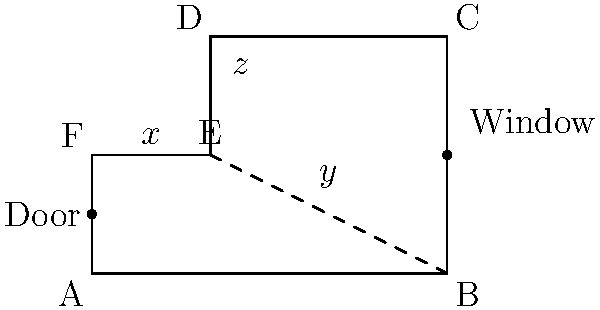In this floor plan of a locked-room mystery scenario, angles $x$, $y$, and $z$ form a crucial part of the crime scene. If $x = 90°$ and $y = 60°$, what is the value of $z$? To solve this problem, we need to follow these steps:

1) First, observe that triangle BDE is formed by the dashed line connecting points B and E.

2) In any triangle, the sum of all interior angles is always 180°. Therefore:
   
   $x + y + z = 180°$

3) We are given that $x = 90°$ and $y = 60°$. Let's substitute these values:
   
   $90° + 60° + z = 180°$

4) Simplify the left side of the equation:
   
   $150° + z = 180°$

5) Subtract 150° from both sides:
   
   $z = 180° - 150° = 30°$

This angle measurement could be crucial in determining the killer's position or the trajectory of a weapon in our locked-room mystery scenario.
Answer: $30°$ 